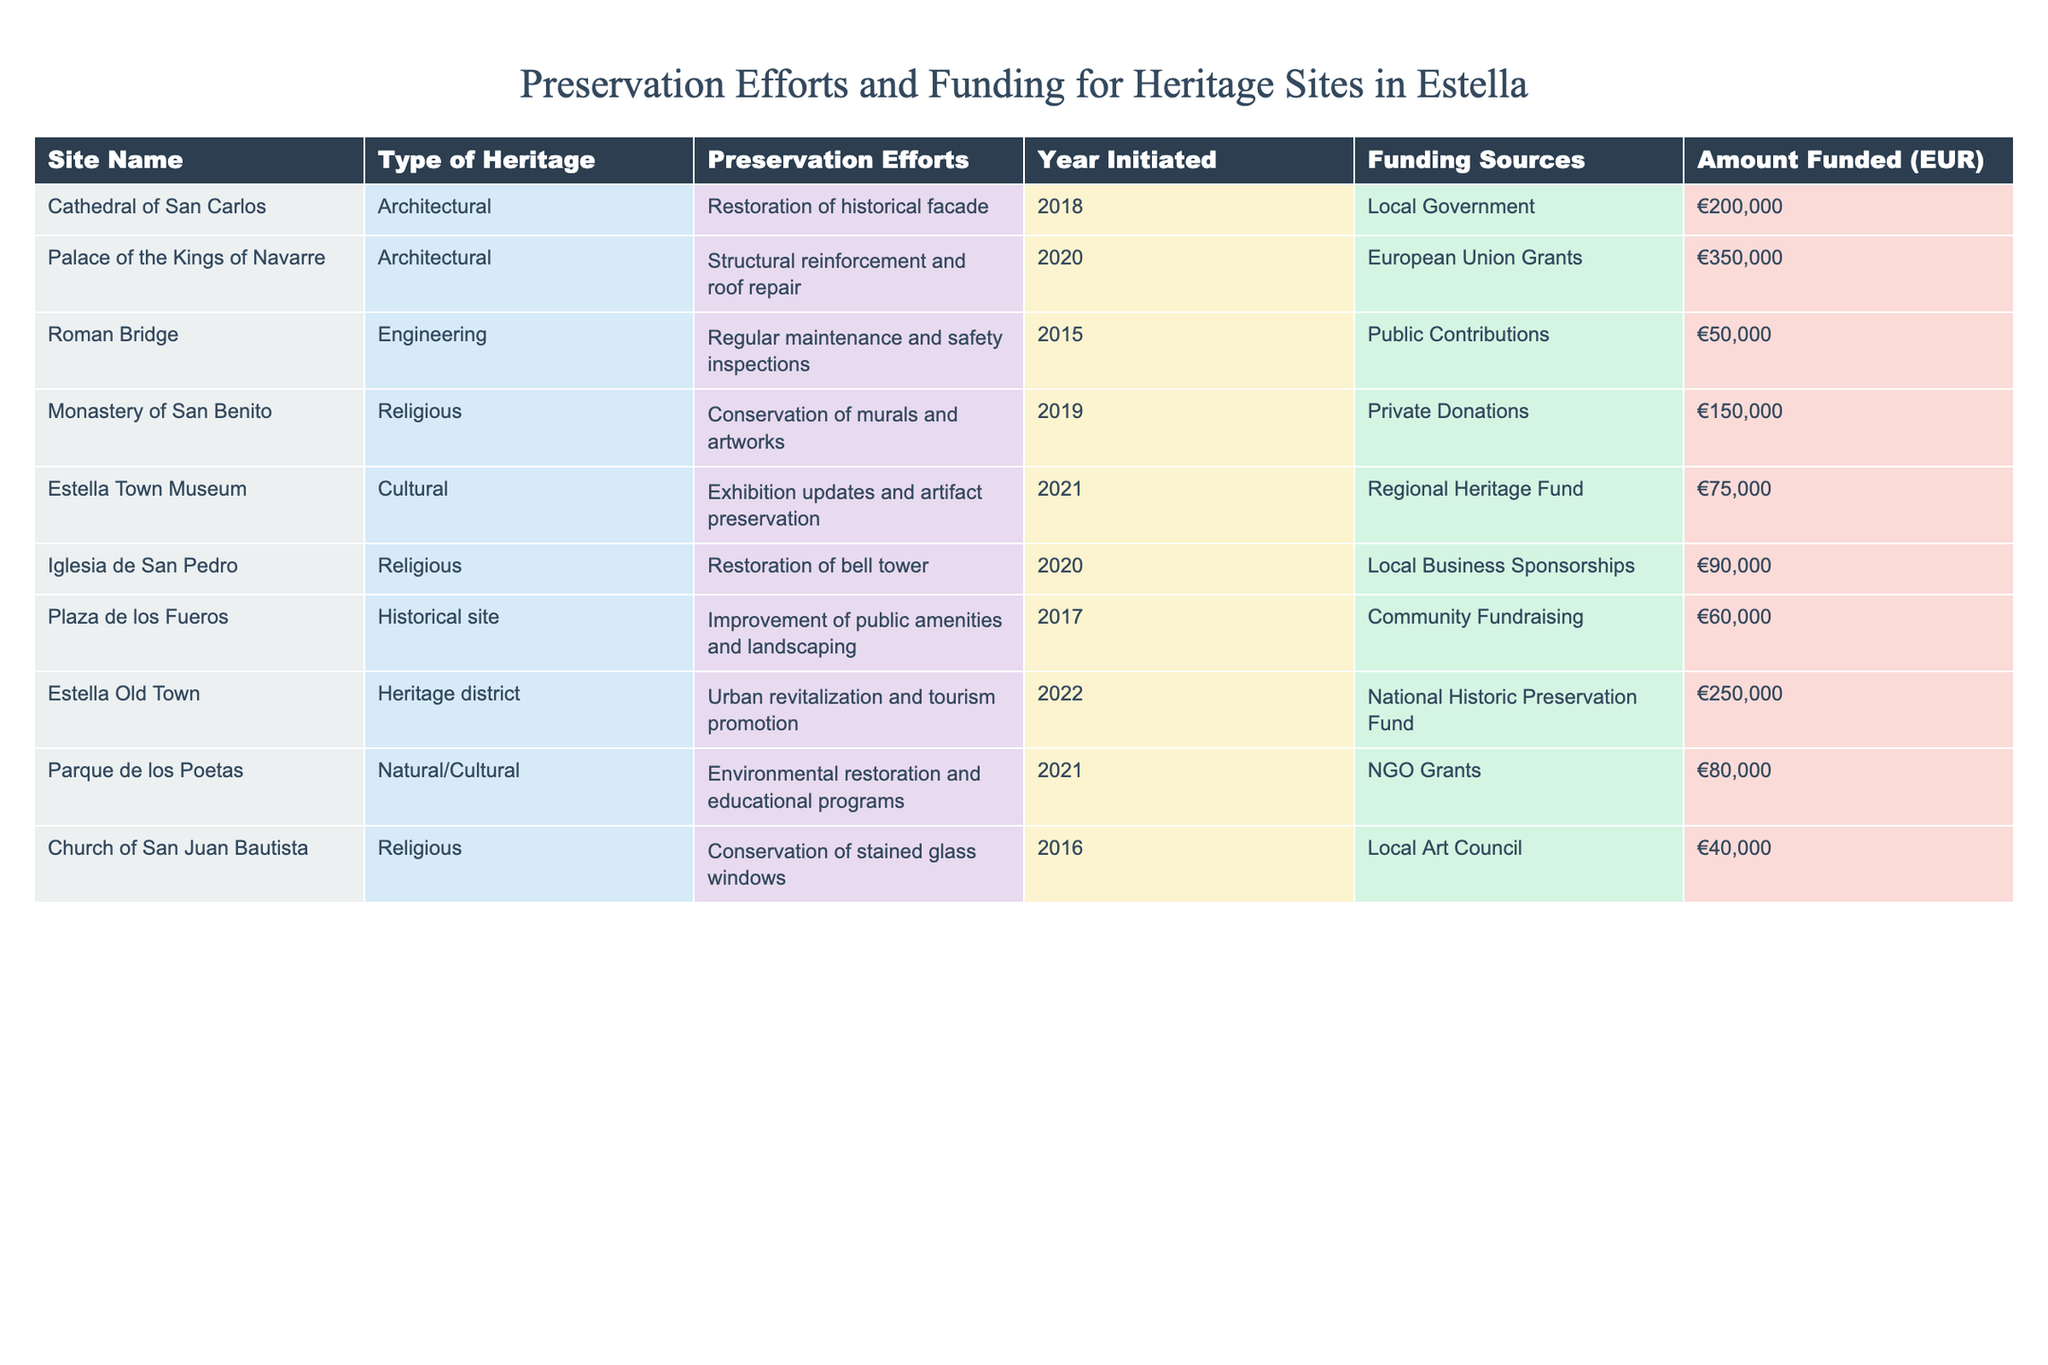What is the total amount funded for all preservation efforts listed in the table? To find the total amount funded, we sum up all the amounts funded for each site: 200000 + 350000 + 50000 + 150000 + 75000 + 90000 + 60000 + 250000 + 80000 + 40000 = 1300000.
Answer: 1300000 Which site received the highest funding for preservation efforts? Looking through the "Amount Funded" column, the Palace of the Kings of Navarre has the highest amount with 350000 EUR.
Answer: Palace of the Kings of Navarre In what year was the restoration of the Cathedral of San Carlos initiated? The table indicates that the restoration efforts for the Cathedral of San Carlos were initiated in 2018.
Answer: 2018 How many sites are funded by Local Government or Local Business Sponsorships? The Cathedral of San Carlos and Plaza de los Fueros are funded by Local Government, and Iglesia de San Pedro is funded by Local Business Sponsorships. Thus, there are 3 sites in total.
Answer: 3 Is the funding for the Roman Bridge greater than the funding for the Church of San Juan Bautista? Comparing the amounts, the Roman Bridge received 50000 EUR, while the Church of San Juan Bautista received 40000 EUR. Since 50000 is greater than 40000, the statement is true.
Answer: Yes What is the average funding amount for sites that are categorized as Religious heritage? The funding amounts for Religious heritage sites are 150000 (Monastery of San Benito), 90000 (Iglesia de San Pedro), and 40000 (Church of San Juan Bautista). The average is calculated as (150000 + 90000 + 40000) / 3 = 110000.
Answer: 110000 Which two funding sources have provided the most financial assistance overall? The European Union Grants (350000 EUR) and Local Government (200000 EUR) resulted in the highest funding amounts. Adding these gives a total of 550000 EUR.
Answer: European Union Grants and Local Government What percentage of the total funding does the Estella Town Museum account for? The funding for Estella Town Museum is 75000 EUR. To find the percentage, we calculate (75000 / 1300000) * 100 = 5.77%.
Answer: 5.77% For which site was the preservation effort initiated most recently? The Estella Old Town, with preservation efforts initiated in 2022, is the most recent.
Answer: Estella Old Town Did any sites receive less than 60000 EUR in funding? Yes, the Roman Bridge received 50000 EUR and the Church of San Juan Bautista received 40000 EUR, both less than 60000 EUR.
Answer: Yes 